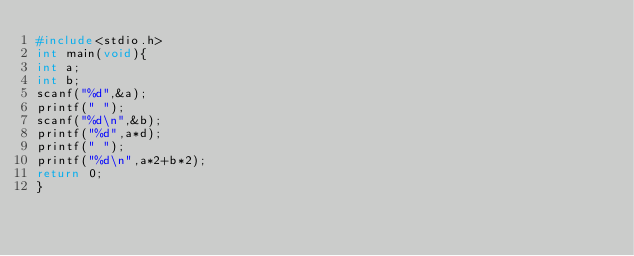<code> <loc_0><loc_0><loc_500><loc_500><_C_>#include<stdio.h>
int main(void){
int a;
int b;
scanf("%d",&a);
printf(" ");
scanf("%d\n",&b);
printf("%d",a*d);
printf(" ");
printf("%d\n",a*2+b*2);
return 0;
}</code> 